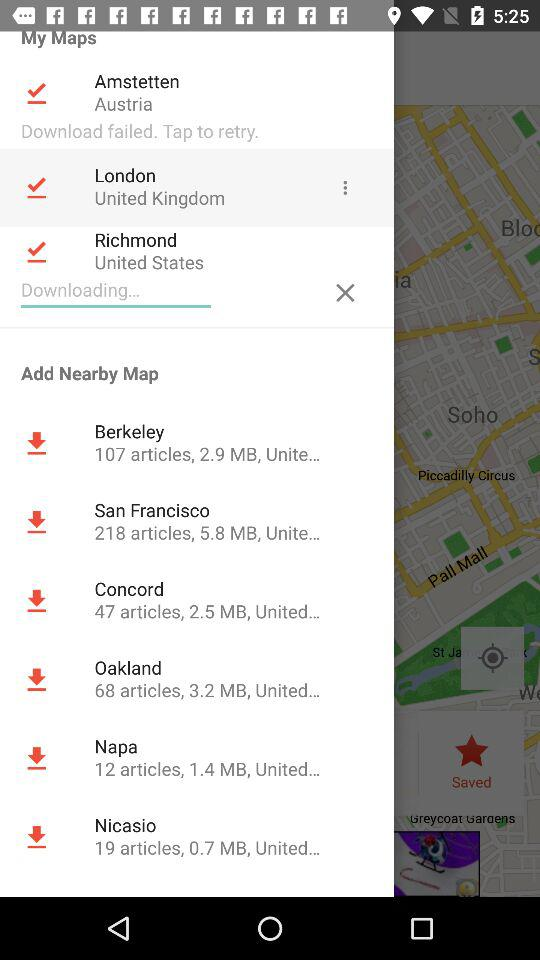What is the size of the San Francisco map? The size is 5.8 MB. 